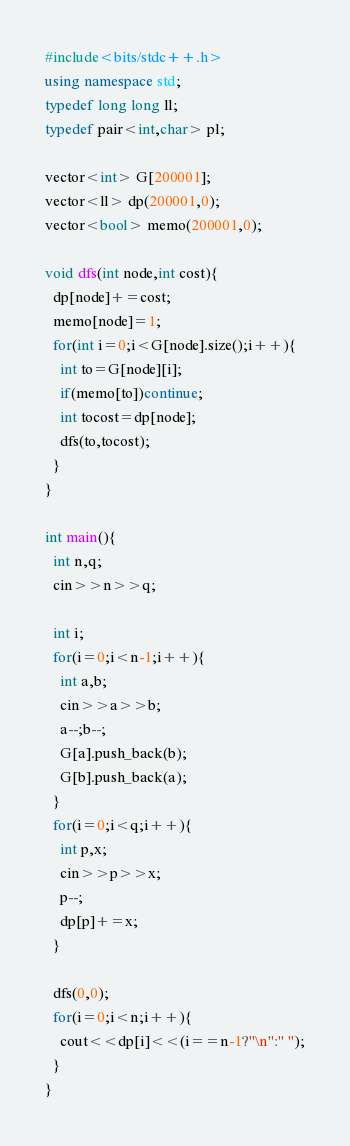Convert code to text. <code><loc_0><loc_0><loc_500><loc_500><_C++_>#include<bits/stdc++.h>
using namespace std;
typedef long long ll;
typedef pair<int,char> pl;

vector<int> G[200001];
vector<ll> dp(200001,0);
vector<bool> memo(200001,0);

void dfs(int node,int cost){
  dp[node]+=cost;
  memo[node]=1;
  for(int i=0;i<G[node].size();i++){
    int to=G[node][i];
    if(memo[to])continue;
    int tocost=dp[node];
    dfs(to,tocost);
  }
}

int main(){
  int n,q;
  cin>>n>>q;

  int i;
  for(i=0;i<n-1;i++){
    int a,b;
    cin>>a>>b;
    a--;b--;
    G[a].push_back(b);
    G[b].push_back(a);
  }
  for(i=0;i<q;i++){
    int p,x;
    cin>>p>>x;
    p--;
    dp[p]+=x;
  }

  dfs(0,0);
  for(i=0;i<n;i++){
    cout<<dp[i]<<(i==n-1?"\n":" ");
  }
}
</code> 